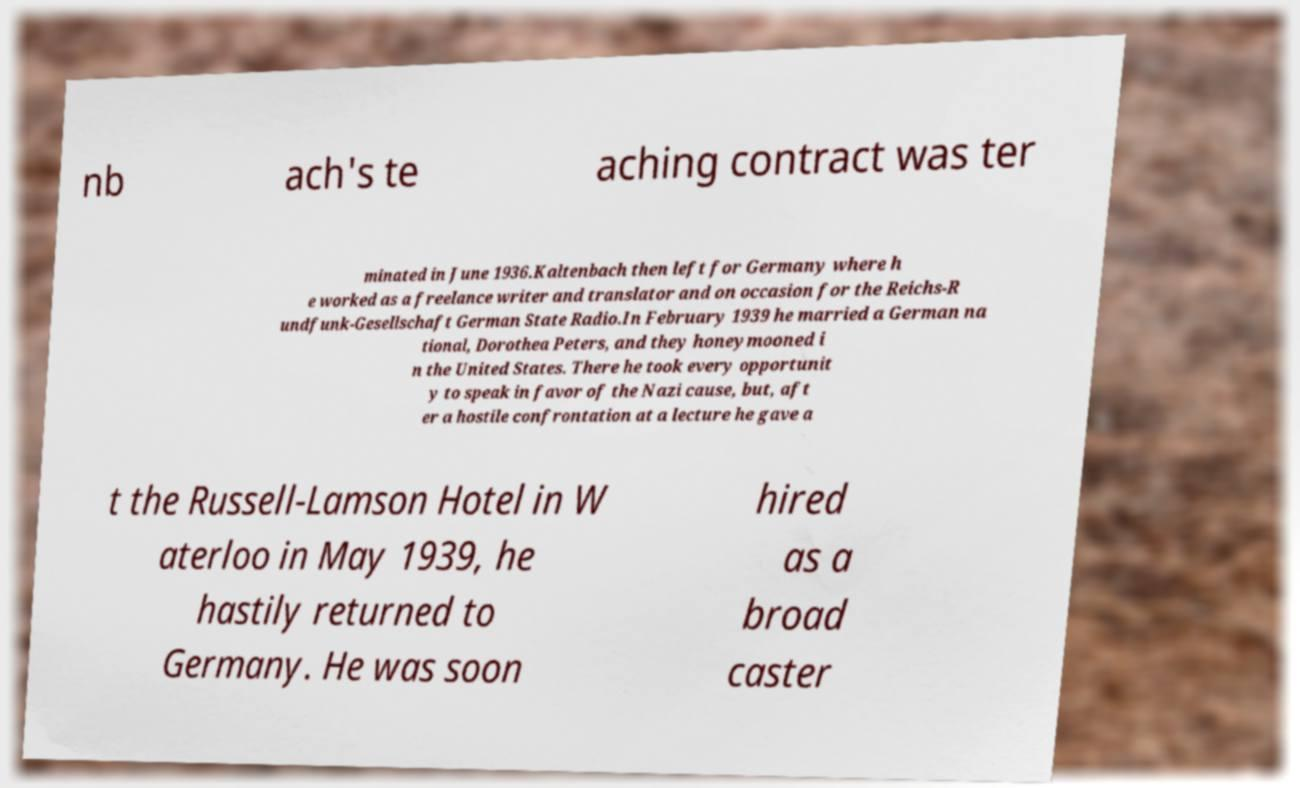Can you accurately transcribe the text from the provided image for me? nb ach's te aching contract was ter minated in June 1936.Kaltenbach then left for Germany where h e worked as a freelance writer and translator and on occasion for the Reichs-R undfunk-Gesellschaft German State Radio.In February 1939 he married a German na tional, Dorothea Peters, and they honeymooned i n the United States. There he took every opportunit y to speak in favor of the Nazi cause, but, aft er a hostile confrontation at a lecture he gave a t the Russell-Lamson Hotel in W aterloo in May 1939, he hastily returned to Germany. He was soon hired as a broad caster 